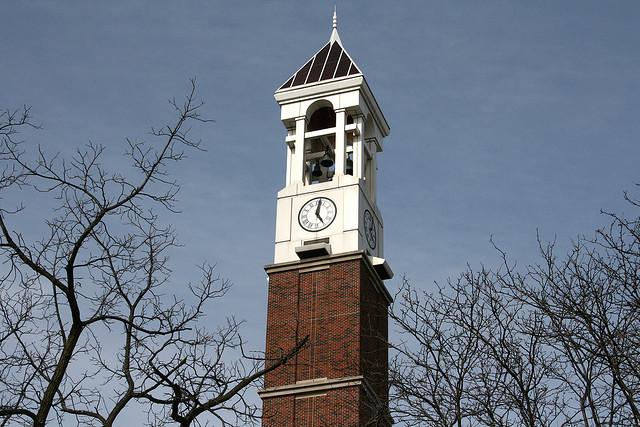At what time do you attend church?
Be succinct. 5:00. Do you see a bell on top?
Short answer required. Yes. Is this a ground up picture?
Answer briefly. Yes. Are there leaves on the trees?
Answer briefly. No. 